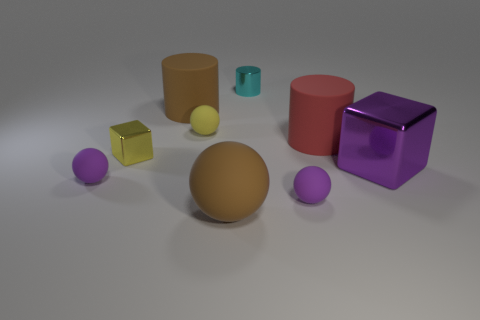Subtract all big rubber cylinders. How many cylinders are left? 1 Subtract all yellow blocks. How many blocks are left? 1 Subtract 3 balls. How many balls are left? 1 Subtract all tiny yellow matte objects. Subtract all red matte objects. How many objects are left? 7 Add 3 big purple things. How many big purple things are left? 4 Add 5 tiny red spheres. How many tiny red spheres exist? 5 Subtract 1 purple blocks. How many objects are left? 8 Subtract all spheres. How many objects are left? 5 Subtract all brown cylinders. Subtract all yellow cubes. How many cylinders are left? 2 Subtract all green cylinders. How many green spheres are left? 0 